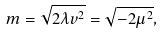<formula> <loc_0><loc_0><loc_500><loc_500>m = \sqrt { 2 \lambda v ^ { 2 } } = \sqrt { - 2 \mu ^ { 2 } } ,</formula> 